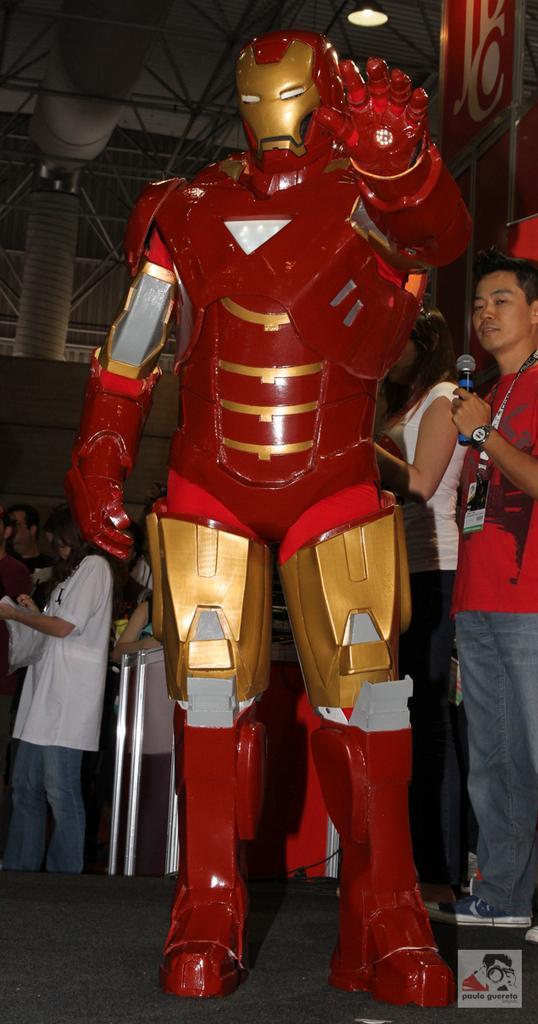Can you describe this image briefly? In this image there is a robot, behind that there are a few people standing and there is an object, one of them is holding a mic, in the background there is a wall. At the top of the image there is a wall and some metal structures with a light. 